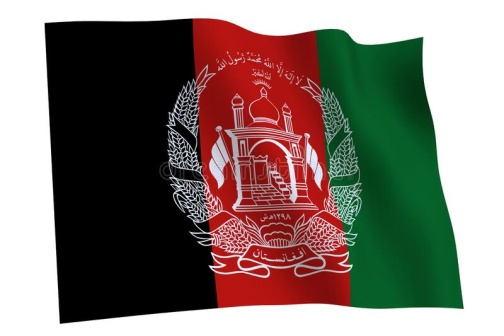Describe the following image. The image displays the vibrant and symbolic national flag of Afghanistan, dynamically waving. It features three vertical stripes: a black one representing the past, a red middle stripe symbolizing the bloodshed for independence, and a green stripe on the right reflecting hope and prosperity. In the center lies a white emblem, intricately designed to include a mosque with a mihrab oriented towards Mecca and a minbar, surrounded by two sheaves of wheat which denote the nation's agricultural roots. An Arabic inscription encircles the mosque, the Shahada, proclaiming the Islamic faith which is central to Afghanistan's identity. 